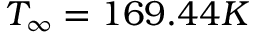<formula> <loc_0><loc_0><loc_500><loc_500>T _ { \infty } = 1 6 9 . 4 4 K</formula> 